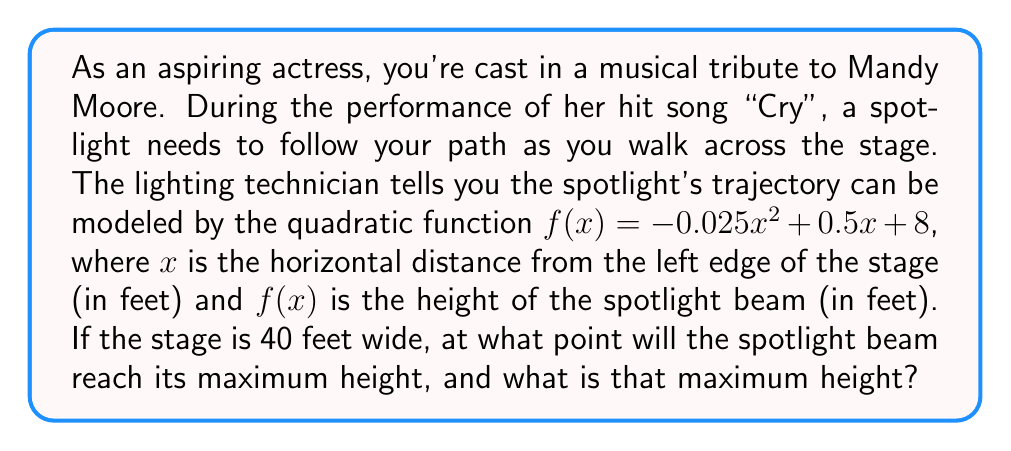Provide a solution to this math problem. To solve this problem, we need to follow these steps:

1) For a quadratic function in the form $f(x) = ax^2 + bx + c$, the x-coordinate of the vertex (which represents the maximum or minimum point) is given by the formula $x = -\frac{b}{2a}$.

2) In our function $f(x) = -0.025x^2 + 0.5x + 8$, we have:
   $a = -0.025$
   $b = 0.5$
   $c = 8$

3) Let's calculate the x-coordinate of the vertex:
   $x = -\frac{b}{2a} = -\frac{0.5}{2(-0.025)} = -\frac{0.5}{-0.05} = 10$

4) This means the spotlight will reach its maximum height when you're 10 feet from the left edge of the stage.

5) To find the maximum height, we need to calculate $f(10)$:
   $f(10) = -0.025(10)^2 + 0.5(10) + 8$
   $= -0.025(100) + 5 + 8$
   $= -2.5 + 5 + 8$
   $= 10.5$

Therefore, the spotlight will reach its maximum height of 10.5 feet when you're 10 feet from the left edge of the stage.
Answer: The spotlight beam will reach its maximum height of 10.5 feet when you're 10 feet from the left edge of the stage. 